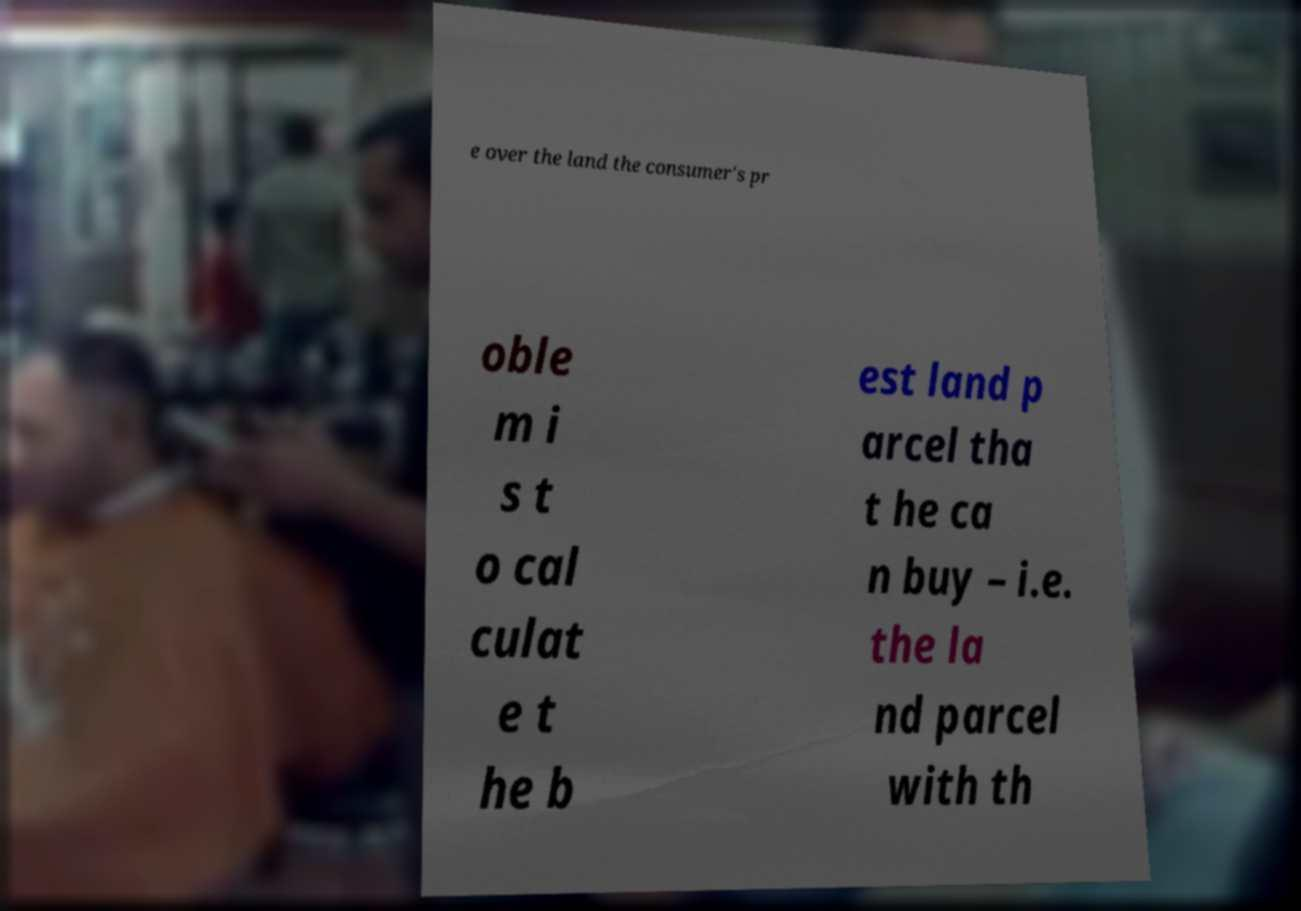Please identify and transcribe the text found in this image. e over the land the consumer's pr oble m i s t o cal culat e t he b est land p arcel tha t he ca n buy – i.e. the la nd parcel with th 